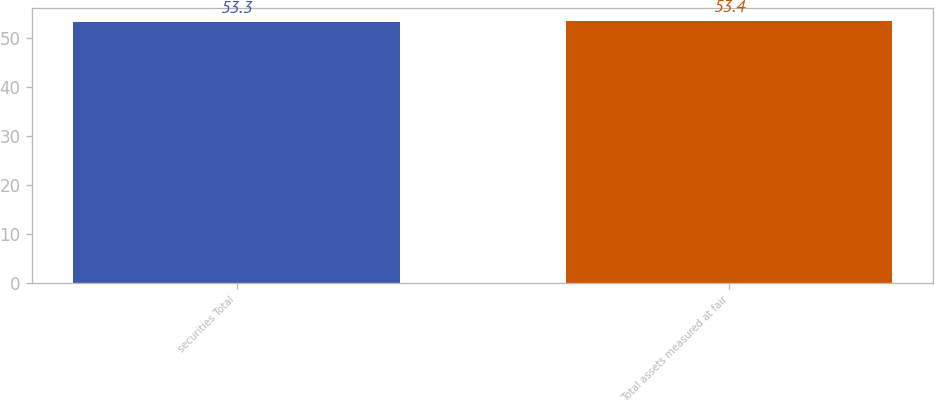<chart> <loc_0><loc_0><loc_500><loc_500><bar_chart><fcel>securities Total<fcel>Total assets measured at fair<nl><fcel>53.3<fcel>53.4<nl></chart> 